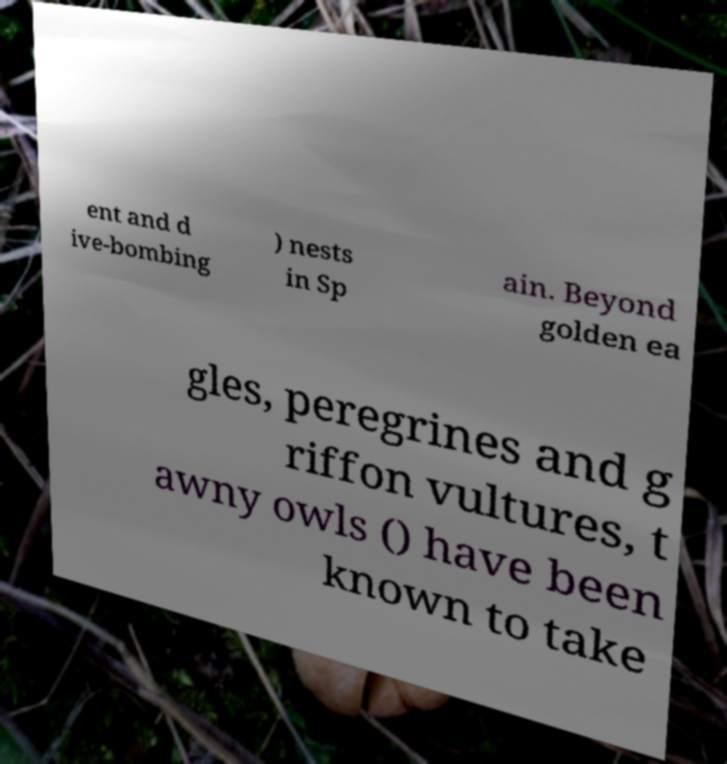Can you accurately transcribe the text from the provided image for me? ent and d ive-bombing ) nests in Sp ain. Beyond golden ea gles, peregrines and g riffon vultures, t awny owls () have been known to take 